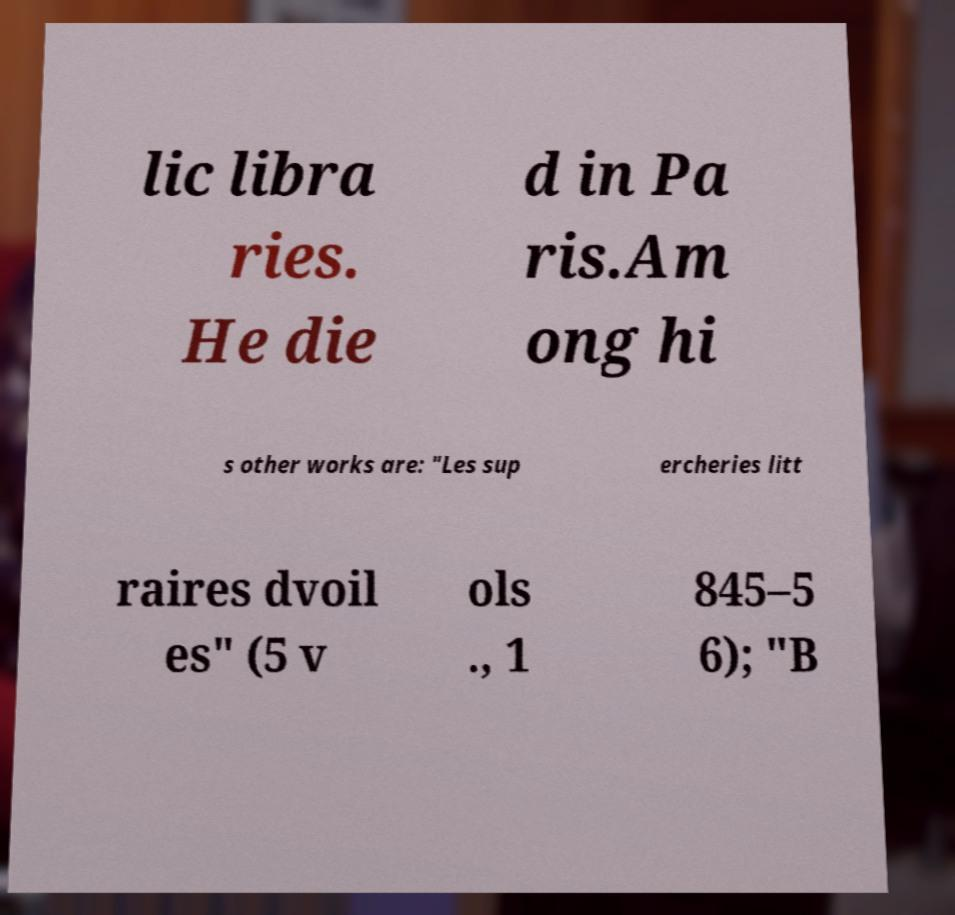Can you read and provide the text displayed in the image?This photo seems to have some interesting text. Can you extract and type it out for me? lic libra ries. He die d in Pa ris.Am ong hi s other works are: "Les sup ercheries litt raires dvoil es" (5 v ols ., 1 845–5 6); "B 